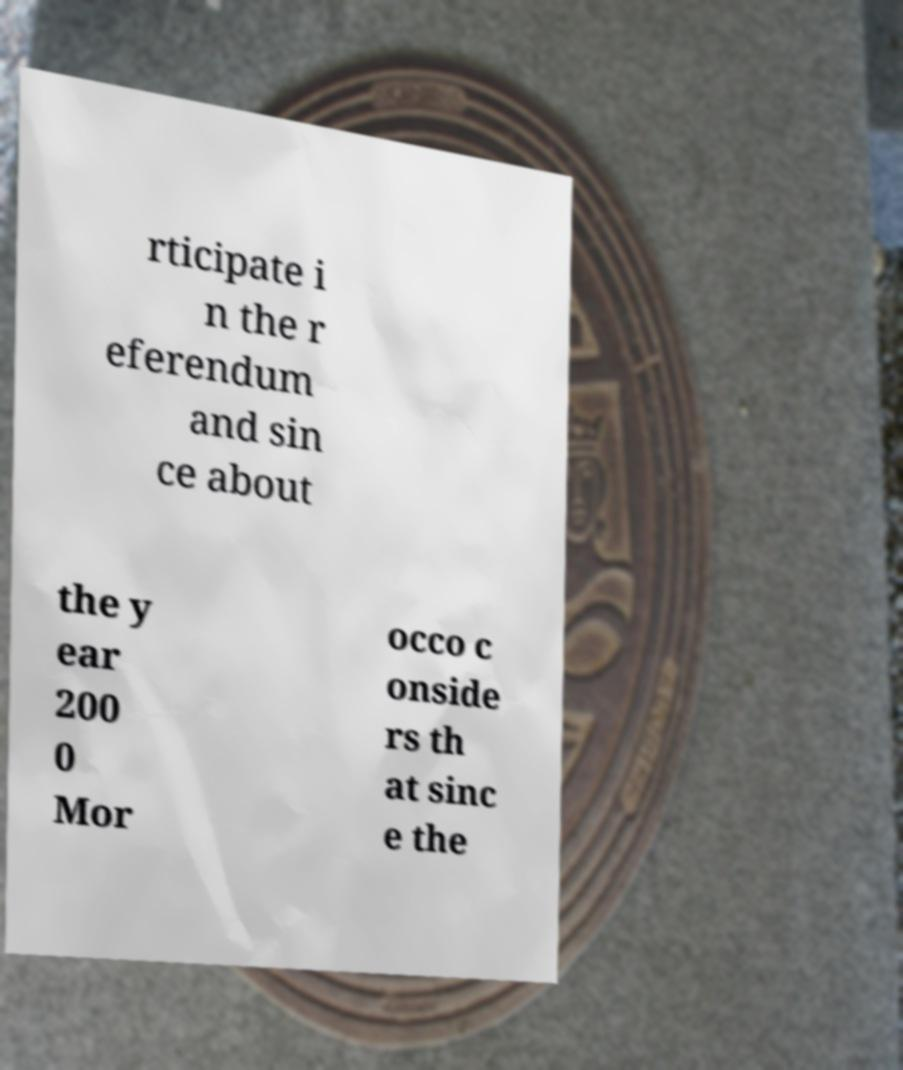Could you extract and type out the text from this image? rticipate i n the r eferendum and sin ce about the y ear 200 0 Mor occo c onside rs th at sinc e the 